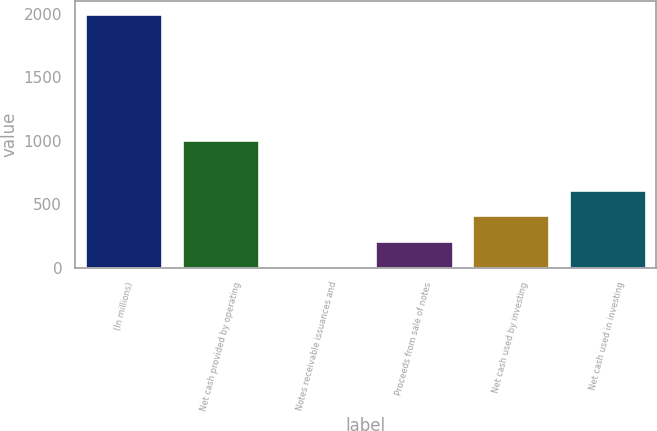<chart> <loc_0><loc_0><loc_500><loc_500><bar_chart><fcel>(In millions)<fcel>Net cash provided by operating<fcel>Notes receivable issuances and<fcel>Proceeds from sale of notes<fcel>Net cash used by investing<fcel>Net cash used in investing<nl><fcel>2004<fcel>1008.8<fcel>13.6<fcel>212.64<fcel>411.68<fcel>610.72<nl></chart> 